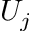Convert formula to latex. <formula><loc_0><loc_0><loc_500><loc_500>U _ { j }</formula> 